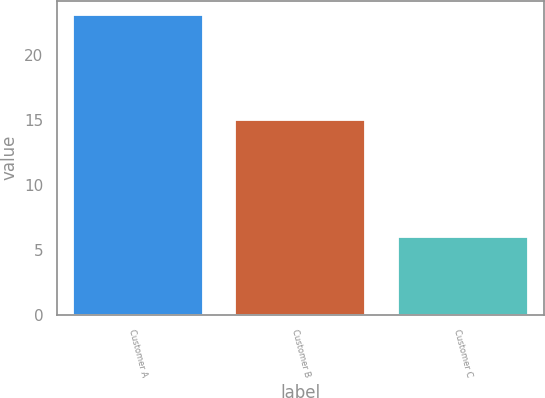Convert chart to OTSL. <chart><loc_0><loc_0><loc_500><loc_500><bar_chart><fcel>Customer A<fcel>Customer B<fcel>Customer C<nl><fcel>23<fcel>15<fcel>6<nl></chart> 